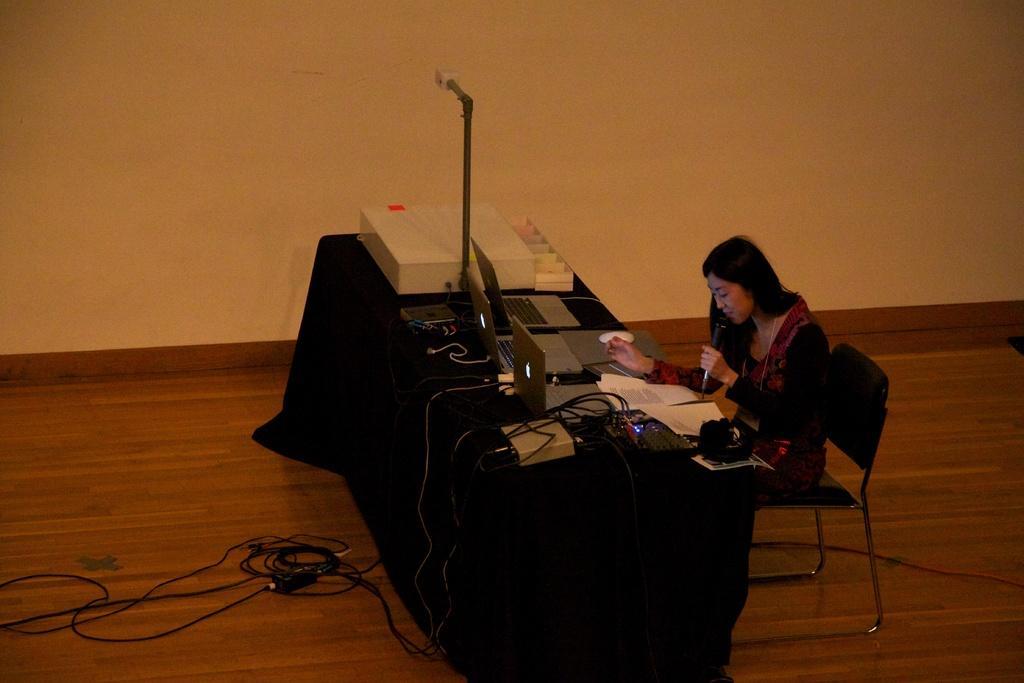Can you describe this image briefly? In this image we can see a woman sitting on the chair and a table is placed in front of her. On the table we can see a printing machine, laptops, cables and a tablecloth. 